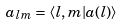<formula> <loc_0><loc_0><loc_500><loc_500>a _ { l m } = \langle l , m | a ( l ) \rangle</formula> 